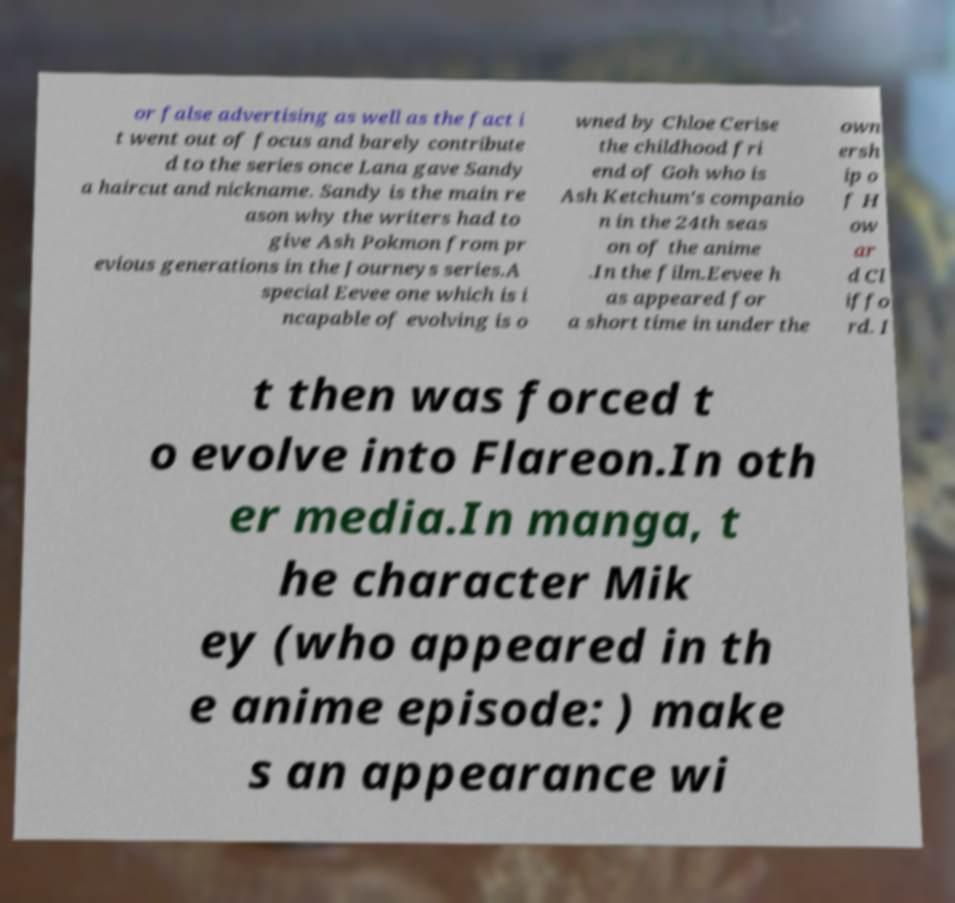Could you assist in decoding the text presented in this image and type it out clearly? or false advertising as well as the fact i t went out of focus and barely contribute d to the series once Lana gave Sandy a haircut and nickname. Sandy is the main re ason why the writers had to give Ash Pokmon from pr evious generations in the Journeys series.A special Eevee one which is i ncapable of evolving is o wned by Chloe Cerise the childhood fri end of Goh who is Ash Ketchum's companio n in the 24th seas on of the anime .In the film.Eevee h as appeared for a short time in under the own ersh ip o f H ow ar d Cl iffo rd. I t then was forced t o evolve into Flareon.In oth er media.In manga, t he character Mik ey (who appeared in th e anime episode: ) make s an appearance wi 